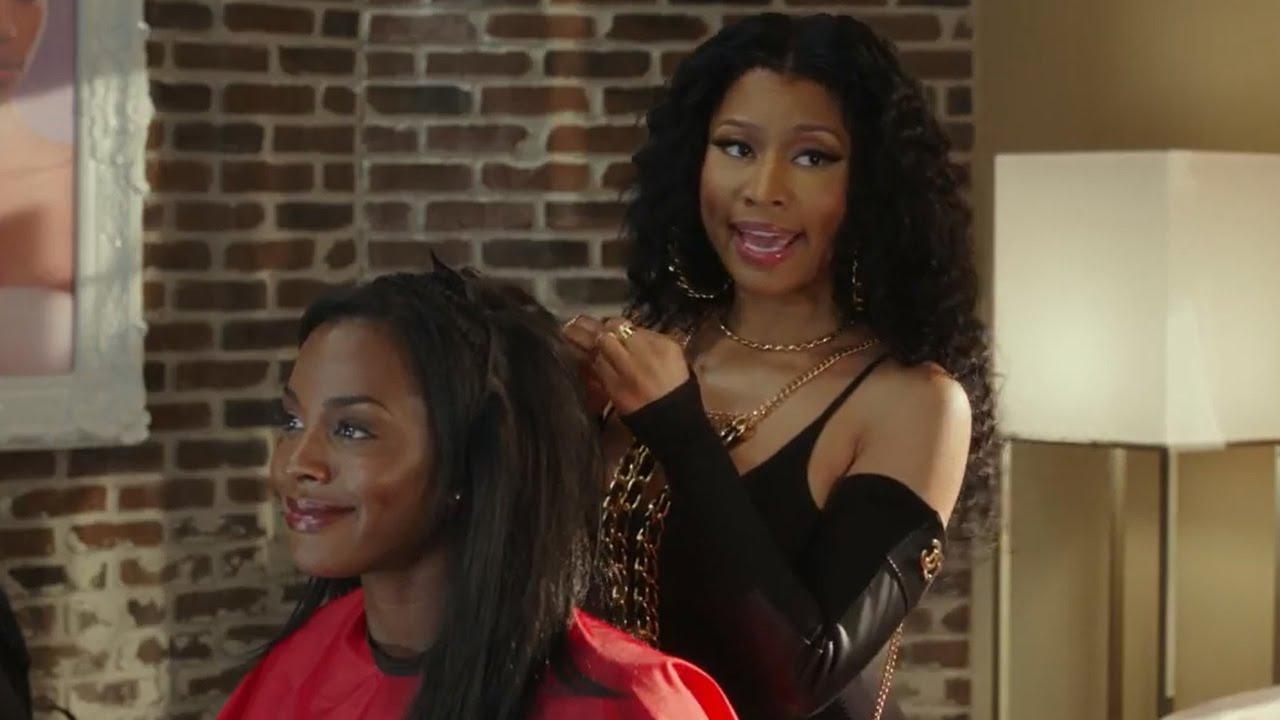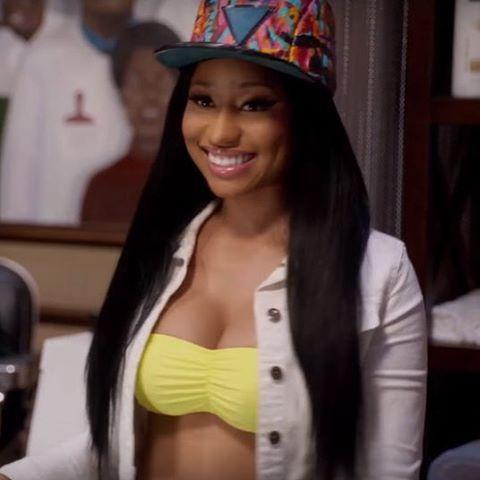The first image is the image on the left, the second image is the image on the right. For the images displayed, is the sentence "A woman is doing another woman's hair in only one of the images." factually correct? Answer yes or no. Yes. The first image is the image on the left, the second image is the image on the right. Analyze the images presented: Is the assertion "Left image shows a stylist behind a customer wearing a red smock, and right image shows a front-facing woman who is not styling hair." valid? Answer yes or no. Yes. 